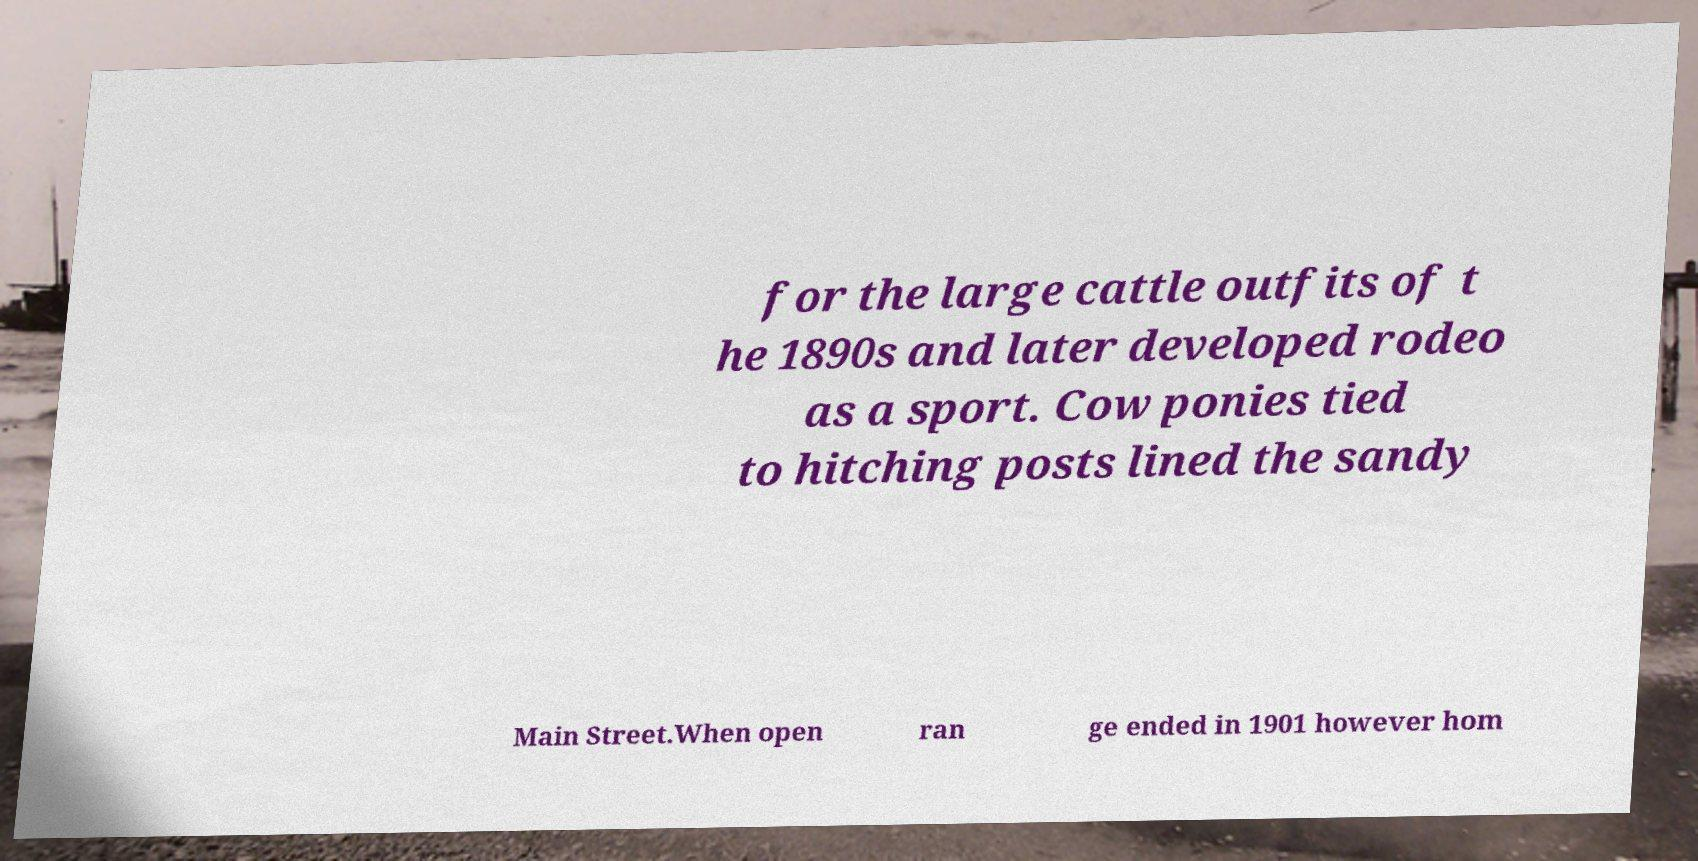There's text embedded in this image that I need extracted. Can you transcribe it verbatim? for the large cattle outfits of t he 1890s and later developed rodeo as a sport. Cow ponies tied to hitching posts lined the sandy Main Street.When open ran ge ended in 1901 however hom 